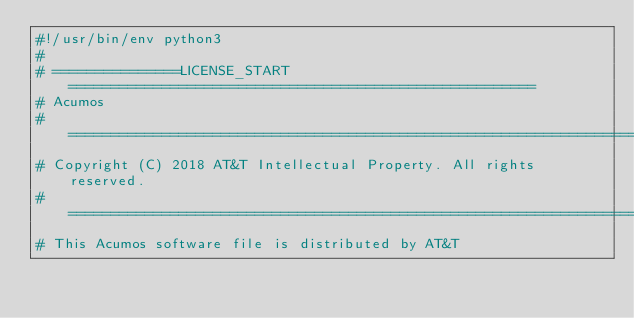Convert code to text. <code><loc_0><loc_0><loc_500><loc_500><_Python_>#!/usr/bin/env python3
#
# ===============LICENSE_START=======================================================
# Acumos
# ===================================================================================
# Copyright (C) 2018 AT&T Intellectual Property. All rights reserved.
# ===================================================================================
# This Acumos software file is distributed by AT&T</code> 